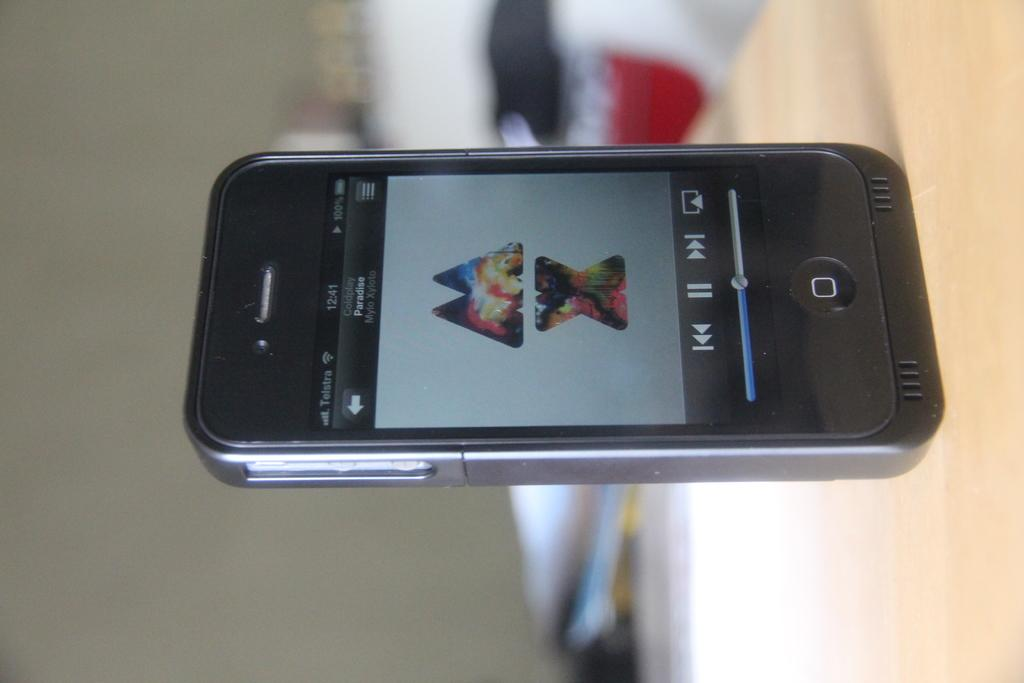<image>
Summarize the visual content of the image. a phone with the time of 12:41 on it 